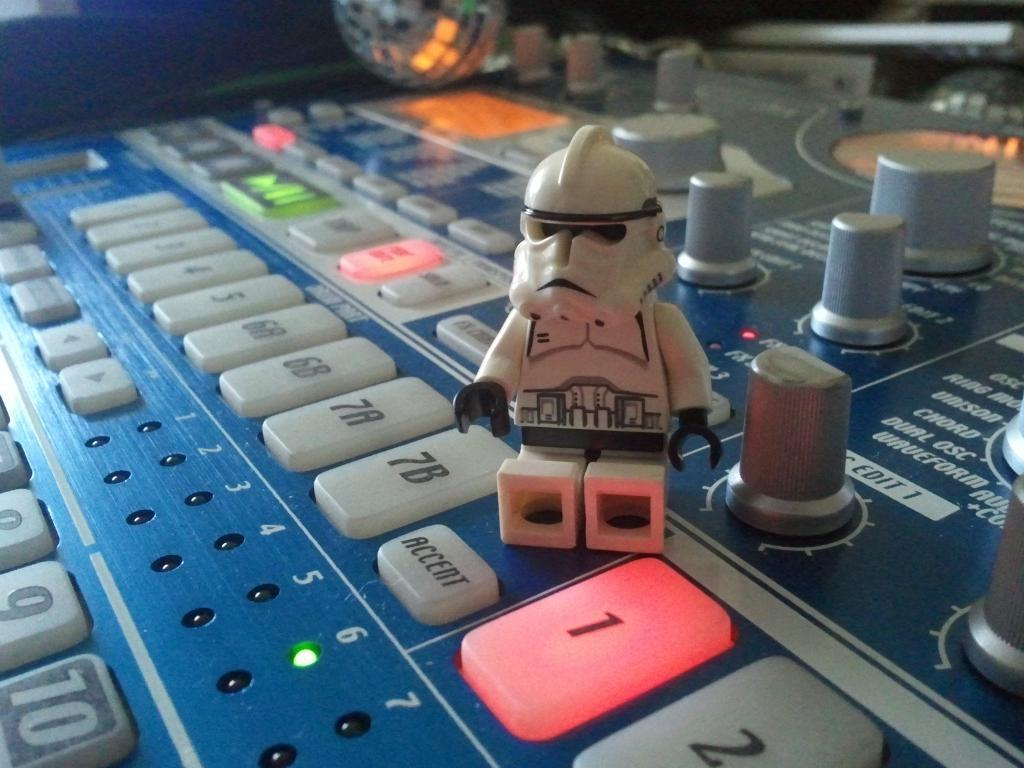<image>
Write a terse but informative summary of the picture. a storm trooper lego on a console with buttons like Accent 